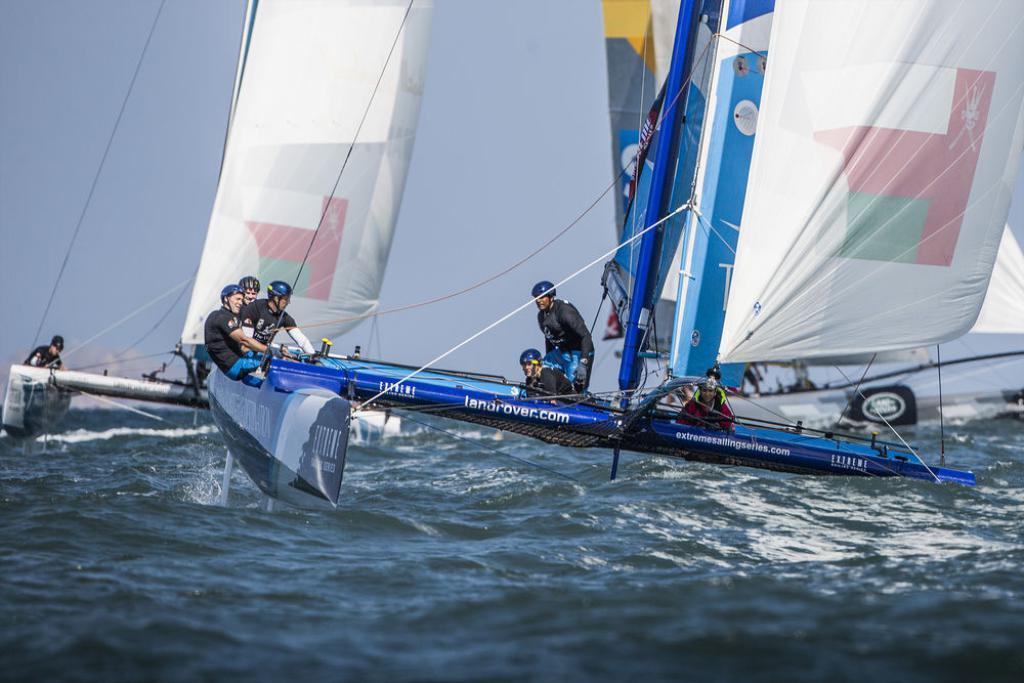In one or two sentences, can you explain what this image depicts? In this picture I can see few boats on the water and on the boats, I can see few people. In the background I can see the sky and I can also see the clothes tied to the boats. 